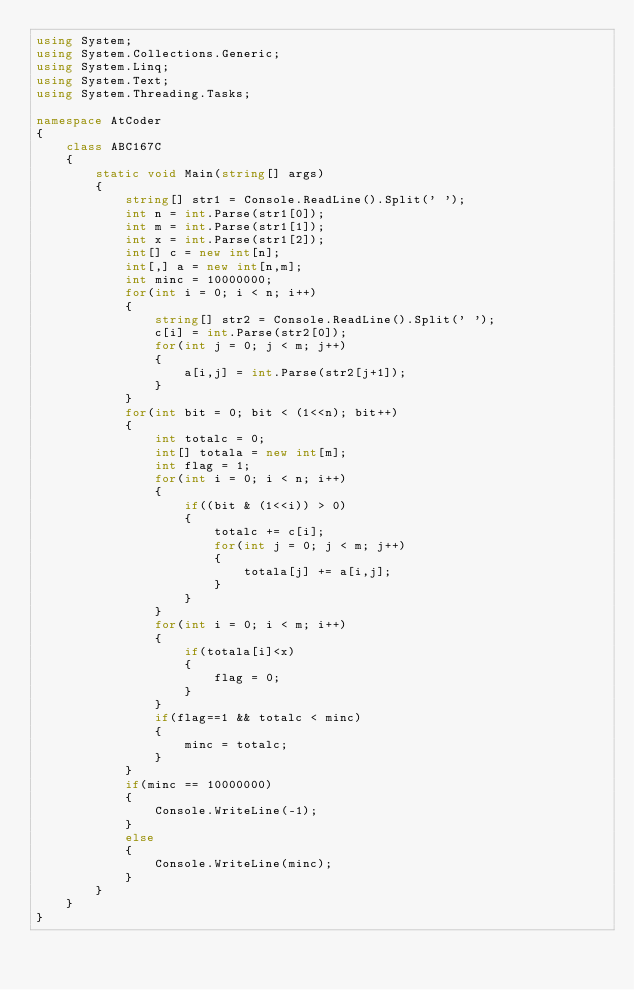<code> <loc_0><loc_0><loc_500><loc_500><_C#_>using System;
using System.Collections.Generic;
using System.Linq;
using System.Text;
using System.Threading.Tasks;
 
namespace AtCoder
{
    class ABC167C
    {
        static void Main(string[] args)
        {
            string[] str1 = Console.ReadLine().Split(' ');
            int n = int.Parse(str1[0]);
            int m = int.Parse(str1[1]);
            int x = int.Parse(str1[2]);
            int[] c = new int[n];
            int[,] a = new int[n,m];
            int minc = 10000000;
            for(int i = 0; i < n; i++)
            {
                string[] str2 = Console.ReadLine().Split(' ');
                c[i] = int.Parse(str2[0]);
                for(int j = 0; j < m; j++)
                {
                    a[i,j] = int.Parse(str2[j+1]);
                }
            }
            for(int bit = 0; bit < (1<<n); bit++)
            {
                int totalc = 0;
                int[] totala = new int[m];
                int flag = 1;
                for(int i = 0; i < n; i++)
                {
                    if((bit & (1<<i)) > 0)
                    {
                        totalc += c[i];
                        for(int j = 0; j < m; j++)
                        {
                            totala[j] += a[i,j];
                        }
                    }
                }
                for(int i = 0; i < m; i++)
                {
                    if(totala[i]<x)
                    {
                        flag = 0;
                    }
                }
                if(flag==1 && totalc < minc)
                {
                    minc = totalc;
                }
            }
            if(minc == 10000000)
            {
                Console.WriteLine(-1);
            }
            else
            {
                Console.WriteLine(minc);
            }
        }
    }
}</code> 